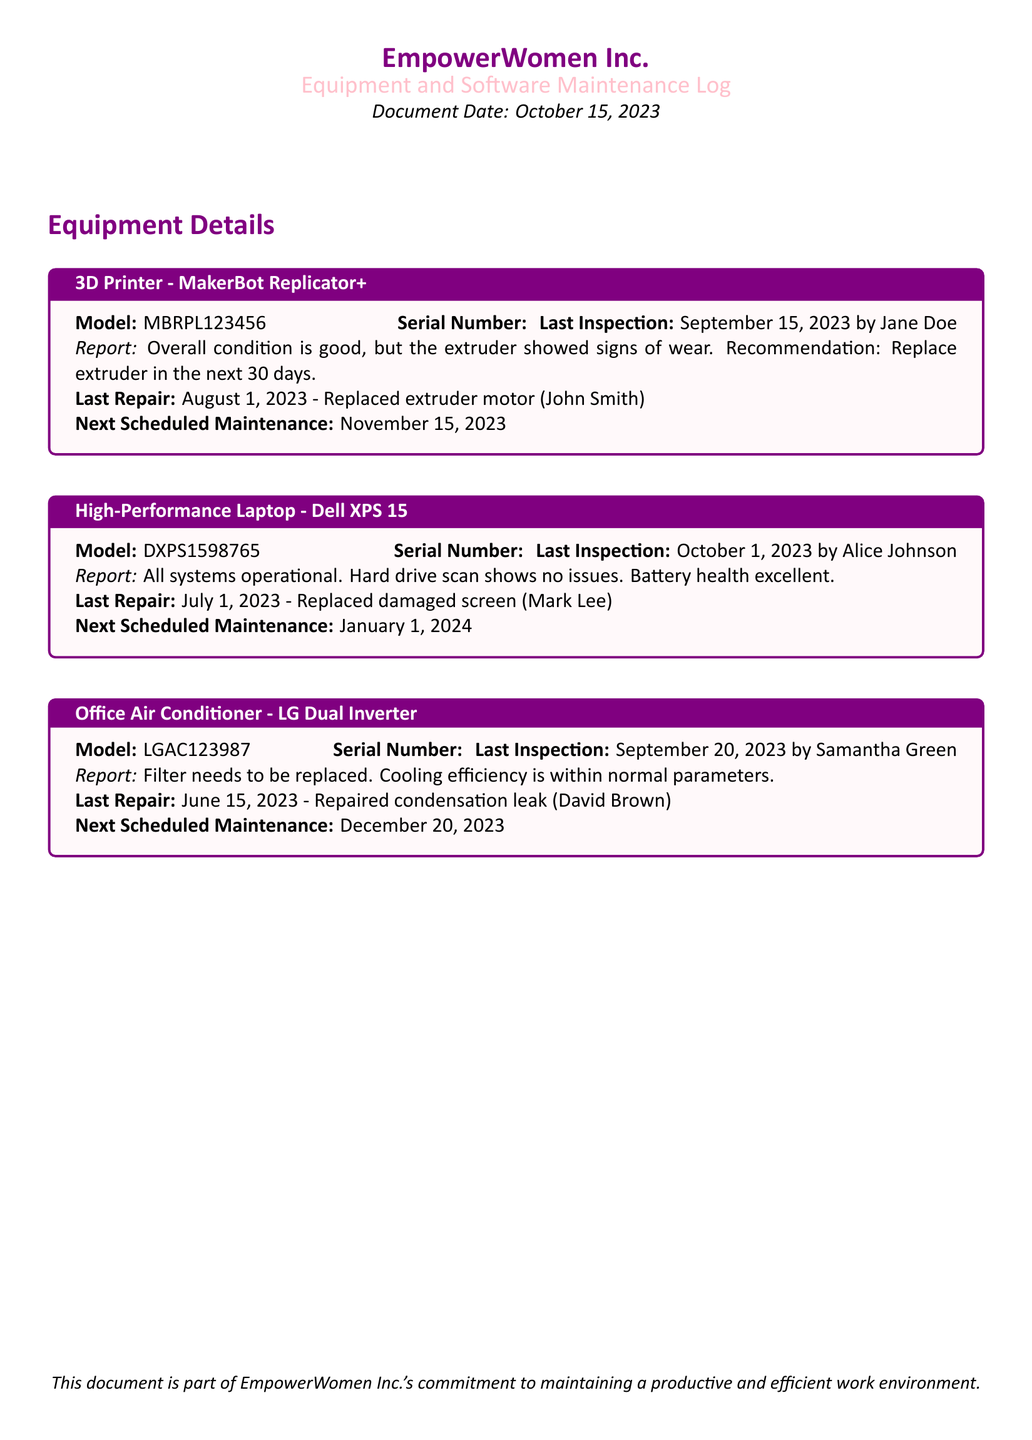What is the model of the 3D printer? The model is explicitly stated in the equipment box for the 3D Printer section.
Answer: MakerBot Replicator+ When was the last inspection of the High-Performance Laptop? The date of the last inspection is provided in the equipment box for the High-Performance Laptop.
Answer: October 1, 2023 Who conducted the last inspection of the Office Air Conditioner? The name of the inspector is mentioned in the inspection report for the Office Air Conditioner.
Answer: Samantha Green What repair was required on the 3D printer, and when was it last repaired? The specific repair and date are detailed in the last repair section of the equipment box for the 3D Printer.
Answer: Replaced extruder motor on August 1, 2023 What is the next scheduled maintenance date for the High-Performance Laptop? The next scheduled maintenance date is provided in the respective equipment box for the High-Performance Laptop.
Answer: January 1, 2024 What issue was reported in the last inspection of the 3D printer? The specific issue found during the last inspection is included in the report for the 3D Printer.
Answer: Extruder showed signs of wear When was the last repair made to the Office Air Conditioner? The last repair date for the Office Air Conditioner is listed in its maintenance log.
Answer: June 15, 2023 What is the cooling efficiency status of the Office Air Conditioner? The report within the equipment box states the efficiency status related to the inspection.
Answer: Normal parameters What type of maintenance log is this document classified as? The title at the top of the document specifies the type of log being maintained.
Answer: Equipment and Software Maintenance Log 